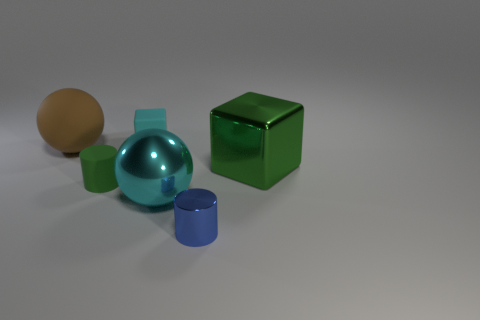What number of objects are either blue shiny objects or matte cubes that are behind the green shiny cube?
Keep it short and to the point. 2. There is a big thing that is on the right side of the sphere that is to the right of the rubber sphere; how many green rubber cylinders are left of it?
Provide a short and direct response. 1. There is a cylinder that is the same color as the big block; what is it made of?
Your answer should be compact. Rubber. What number of metal blocks are there?
Offer a very short reply. 1. Do the cube on the right side of the blue metallic cylinder and the big brown rubber ball have the same size?
Ensure brevity in your answer.  Yes. How many metallic things are either small gray spheres or small green cylinders?
Give a very brief answer. 0. What number of big brown rubber things are left of the matte object that is in front of the large brown matte thing?
Offer a terse response. 1. What shape is the rubber object that is both behind the green metal thing and on the right side of the brown sphere?
Offer a terse response. Cube. What material is the ball on the right side of the sphere behind the block that is to the right of the large cyan shiny sphere?
Your answer should be very brief. Metal. What is the size of the block that is the same color as the small matte cylinder?
Your response must be concise. Large. 